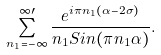Convert formula to latex. <formula><loc_0><loc_0><loc_500><loc_500>\sum _ { n _ { 1 } = - \infty } ^ { \infty \prime } \frac { e ^ { i \pi n _ { 1 } ( \alpha - 2 \sigma ) } } { n _ { 1 } S i n ( \pi n _ { 1 } \alpha ) } .</formula> 